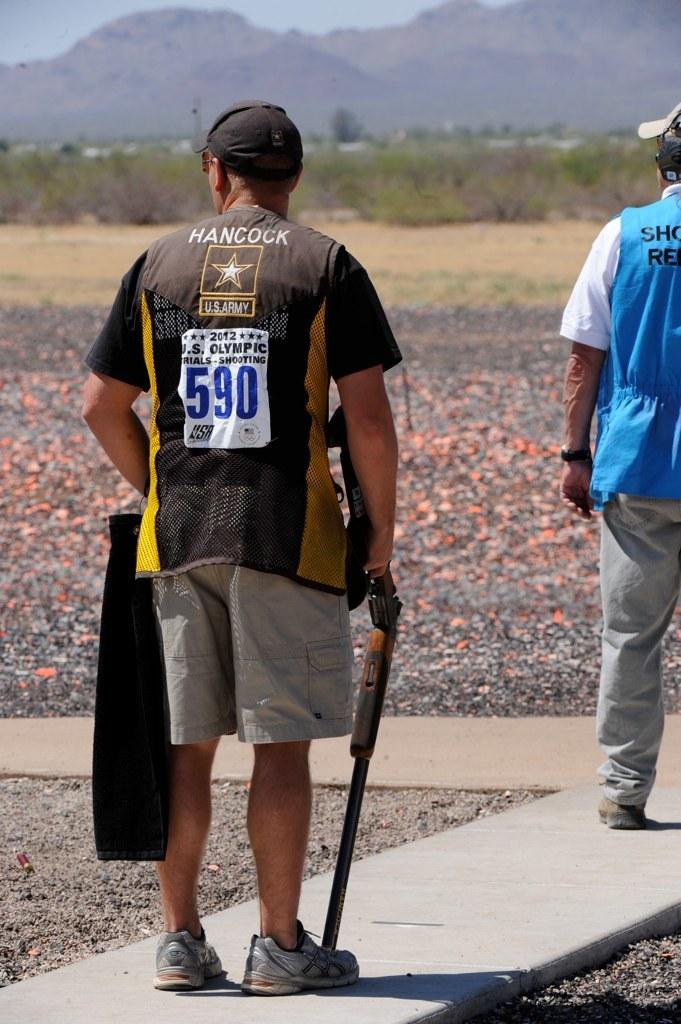<image>
Give a short and clear explanation of the subsequent image. US olympic trials shooting contestants are on the field 